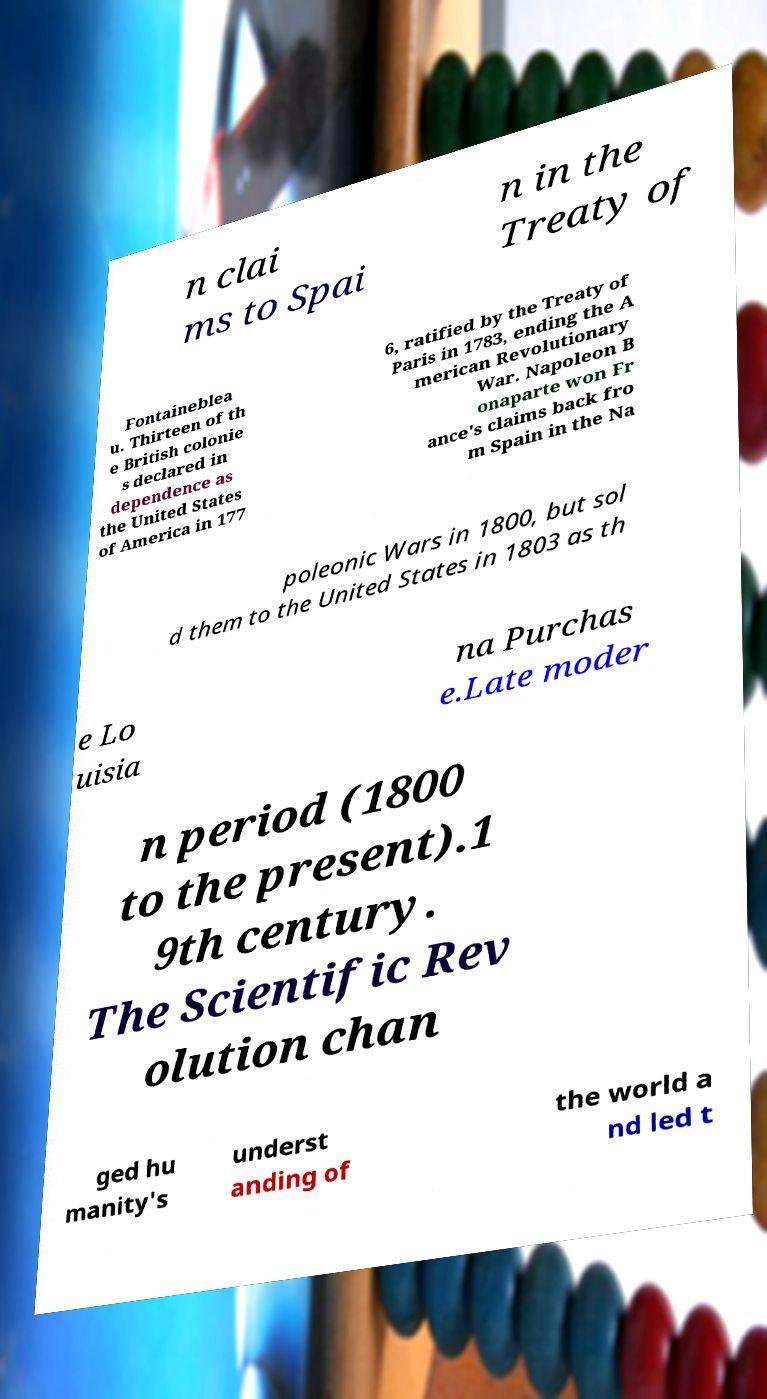Can you accurately transcribe the text from the provided image for me? n clai ms to Spai n in the Treaty of Fontaineblea u. Thirteen of th e British colonie s declared in dependence as the United States of America in 177 6, ratified by the Treaty of Paris in 1783, ending the A merican Revolutionary War. Napoleon B onaparte won Fr ance's claims back fro m Spain in the Na poleonic Wars in 1800, but sol d them to the United States in 1803 as th e Lo uisia na Purchas e.Late moder n period (1800 to the present).1 9th century. The Scientific Rev olution chan ged hu manity's underst anding of the world a nd led t 